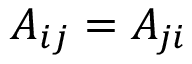Convert formula to latex. <formula><loc_0><loc_0><loc_500><loc_500>A _ { i j } = A _ { j i }</formula> 